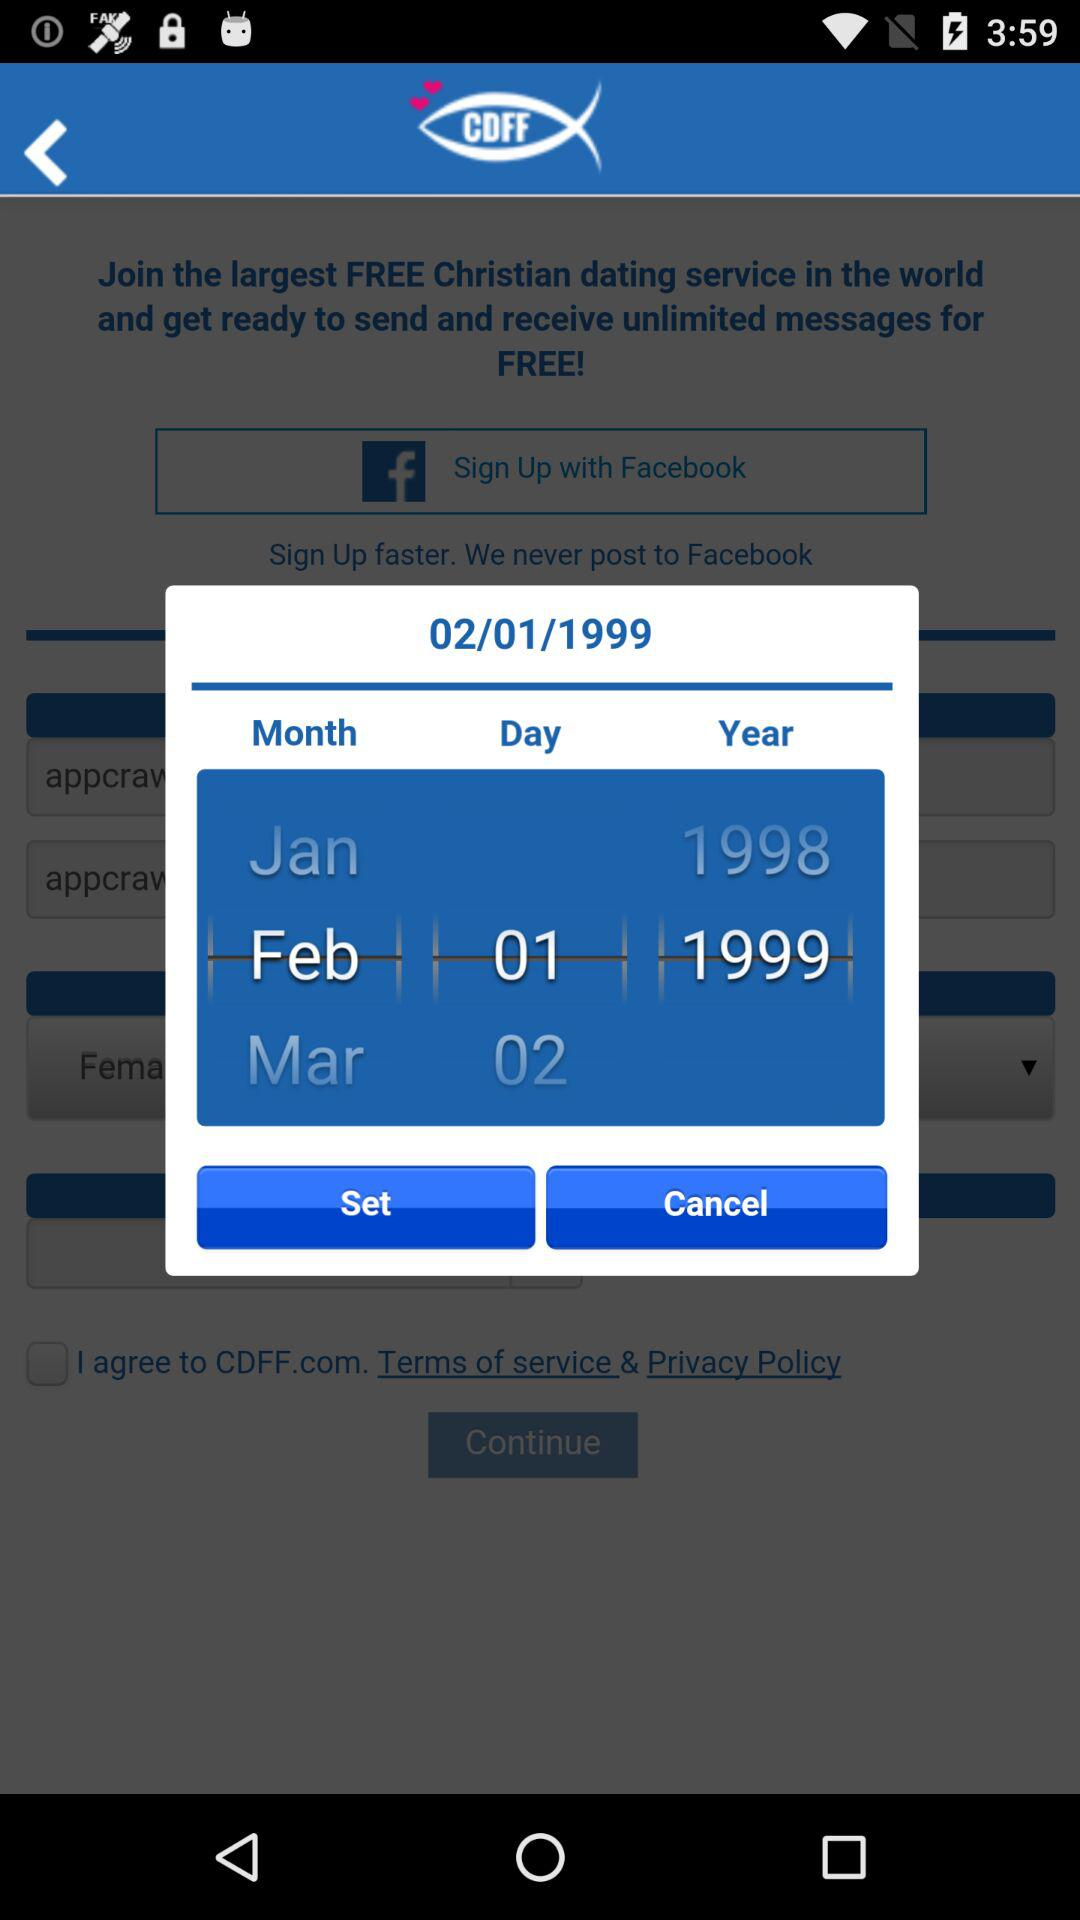How many years are between the earliest and latest dates shown?
Answer the question using a single word or phrase. 1 